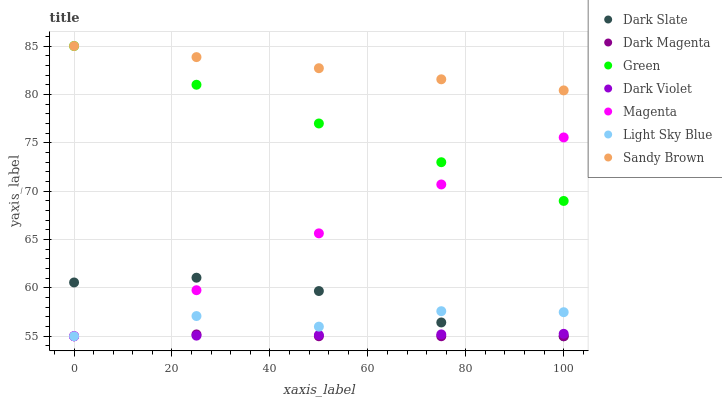Does Dark Magenta have the minimum area under the curve?
Answer yes or no. Yes. Does Sandy Brown have the maximum area under the curve?
Answer yes or no. Yes. Does Dark Violet have the minimum area under the curve?
Answer yes or no. No. Does Dark Violet have the maximum area under the curve?
Answer yes or no. No. Is Green the smoothest?
Answer yes or no. Yes. Is Light Sky Blue the roughest?
Answer yes or no. Yes. Is Dark Violet the smoothest?
Answer yes or no. No. Is Dark Violet the roughest?
Answer yes or no. No. Does Dark Magenta have the lowest value?
Answer yes or no. Yes. Does Green have the lowest value?
Answer yes or no. No. Does Sandy Brown have the highest value?
Answer yes or no. Yes. Does Dark Violet have the highest value?
Answer yes or no. No. Is Dark Violet less than Sandy Brown?
Answer yes or no. Yes. Is Green greater than Dark Violet?
Answer yes or no. Yes. Does Magenta intersect Dark Violet?
Answer yes or no. Yes. Is Magenta less than Dark Violet?
Answer yes or no. No. Is Magenta greater than Dark Violet?
Answer yes or no. No. Does Dark Violet intersect Sandy Brown?
Answer yes or no. No. 